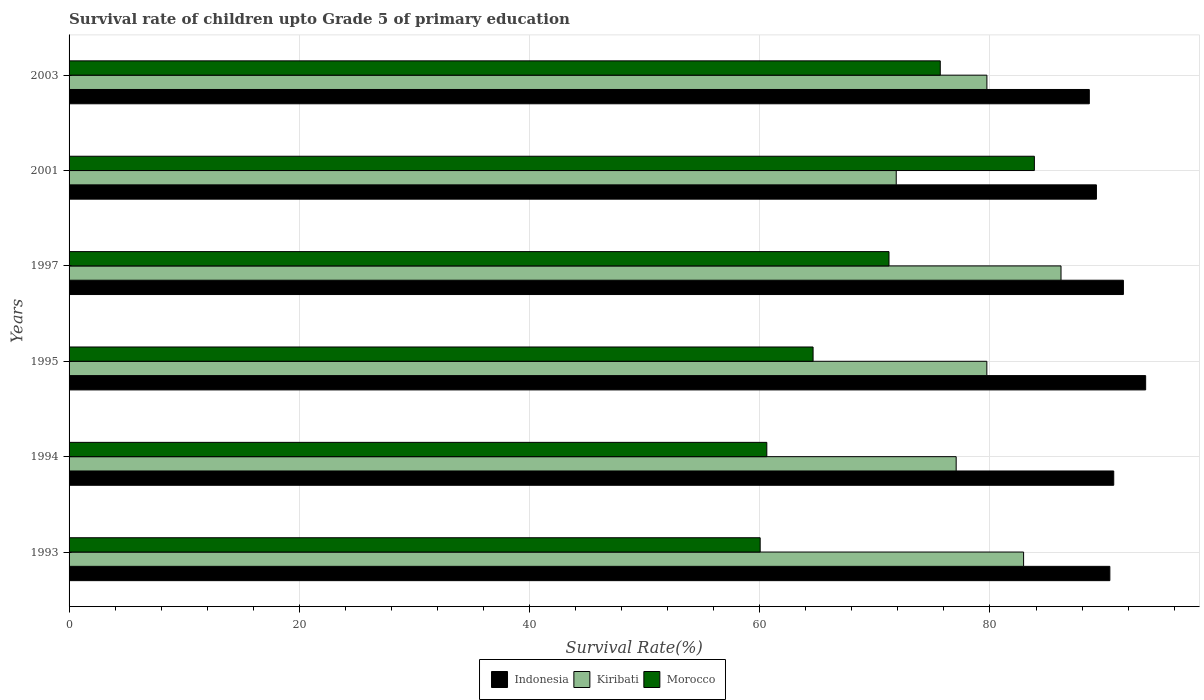How many different coloured bars are there?
Give a very brief answer. 3. How many groups of bars are there?
Provide a succinct answer. 6. Are the number of bars per tick equal to the number of legend labels?
Make the answer very short. Yes. Are the number of bars on each tick of the Y-axis equal?
Provide a short and direct response. Yes. How many bars are there on the 4th tick from the bottom?
Keep it short and to the point. 3. In how many cases, is the number of bars for a given year not equal to the number of legend labels?
Your answer should be compact. 0. What is the survival rate of children in Kiribati in 1995?
Your answer should be very brief. 79.73. Across all years, what is the maximum survival rate of children in Morocco?
Keep it short and to the point. 83.86. Across all years, what is the minimum survival rate of children in Morocco?
Your answer should be compact. 60.04. In which year was the survival rate of children in Morocco minimum?
Give a very brief answer. 1993. What is the total survival rate of children in Indonesia in the graph?
Your answer should be very brief. 544.16. What is the difference between the survival rate of children in Kiribati in 1995 and that in 2003?
Provide a short and direct response. -0.01. What is the difference between the survival rate of children in Morocco in 1997 and the survival rate of children in Indonesia in 2001?
Your answer should be very brief. -18.02. What is the average survival rate of children in Morocco per year?
Your answer should be very brief. 69.34. In the year 1993, what is the difference between the survival rate of children in Indonesia and survival rate of children in Kiribati?
Provide a short and direct response. 7.49. What is the ratio of the survival rate of children in Morocco in 1993 to that in 2001?
Provide a succinct answer. 0.72. Is the survival rate of children in Indonesia in 1994 less than that in 2001?
Offer a very short reply. No. Is the difference between the survival rate of children in Indonesia in 1993 and 1994 greater than the difference between the survival rate of children in Kiribati in 1993 and 1994?
Make the answer very short. No. What is the difference between the highest and the second highest survival rate of children in Kiribati?
Give a very brief answer. 3.25. What is the difference between the highest and the lowest survival rate of children in Kiribati?
Give a very brief answer. 14.31. In how many years, is the survival rate of children in Morocco greater than the average survival rate of children in Morocco taken over all years?
Your response must be concise. 3. Is the sum of the survival rate of children in Kiribati in 1997 and 2001 greater than the maximum survival rate of children in Indonesia across all years?
Your response must be concise. Yes. What does the 3rd bar from the top in 2001 represents?
Ensure brevity in your answer.  Indonesia. How many bars are there?
Your response must be concise. 18. How many years are there in the graph?
Your response must be concise. 6. Does the graph contain any zero values?
Provide a short and direct response. No. Does the graph contain grids?
Make the answer very short. Yes. What is the title of the graph?
Ensure brevity in your answer.  Survival rate of children upto Grade 5 of primary education. Does "Malaysia" appear as one of the legend labels in the graph?
Your response must be concise. No. What is the label or title of the X-axis?
Keep it short and to the point. Survival Rate(%). What is the Survival Rate(%) in Indonesia in 1993?
Make the answer very short. 90.41. What is the Survival Rate(%) of Kiribati in 1993?
Offer a terse response. 82.92. What is the Survival Rate(%) in Morocco in 1993?
Give a very brief answer. 60.04. What is the Survival Rate(%) of Indonesia in 1994?
Provide a succinct answer. 90.75. What is the Survival Rate(%) in Kiribati in 1994?
Give a very brief answer. 77.06. What is the Survival Rate(%) in Morocco in 1994?
Give a very brief answer. 60.61. What is the Survival Rate(%) of Indonesia in 1995?
Your answer should be very brief. 93.52. What is the Survival Rate(%) in Kiribati in 1995?
Provide a short and direct response. 79.73. What is the Survival Rate(%) of Morocco in 1995?
Ensure brevity in your answer.  64.63. What is the Survival Rate(%) in Indonesia in 1997?
Ensure brevity in your answer.  91.59. What is the Survival Rate(%) of Kiribati in 1997?
Provide a short and direct response. 86.17. What is the Survival Rate(%) of Morocco in 1997?
Ensure brevity in your answer.  71.23. What is the Survival Rate(%) in Indonesia in 2001?
Make the answer very short. 89.25. What is the Survival Rate(%) of Kiribati in 2001?
Ensure brevity in your answer.  71.86. What is the Survival Rate(%) in Morocco in 2001?
Your answer should be compact. 83.86. What is the Survival Rate(%) in Indonesia in 2003?
Your answer should be compact. 88.63. What is the Survival Rate(%) of Kiribati in 2003?
Provide a short and direct response. 79.73. What is the Survival Rate(%) of Morocco in 2003?
Ensure brevity in your answer.  75.68. Across all years, what is the maximum Survival Rate(%) in Indonesia?
Give a very brief answer. 93.52. Across all years, what is the maximum Survival Rate(%) in Kiribati?
Provide a short and direct response. 86.17. Across all years, what is the maximum Survival Rate(%) of Morocco?
Make the answer very short. 83.86. Across all years, what is the minimum Survival Rate(%) of Indonesia?
Give a very brief answer. 88.63. Across all years, what is the minimum Survival Rate(%) in Kiribati?
Offer a very short reply. 71.86. Across all years, what is the minimum Survival Rate(%) in Morocco?
Your answer should be very brief. 60.04. What is the total Survival Rate(%) of Indonesia in the graph?
Keep it short and to the point. 544.16. What is the total Survival Rate(%) in Kiribati in the graph?
Your response must be concise. 477.47. What is the total Survival Rate(%) in Morocco in the graph?
Make the answer very short. 416.05. What is the difference between the Survival Rate(%) in Indonesia in 1993 and that in 1994?
Ensure brevity in your answer.  -0.34. What is the difference between the Survival Rate(%) of Kiribati in 1993 and that in 1994?
Your answer should be very brief. 5.86. What is the difference between the Survival Rate(%) in Morocco in 1993 and that in 1994?
Provide a short and direct response. -0.58. What is the difference between the Survival Rate(%) of Indonesia in 1993 and that in 1995?
Your response must be concise. -3.11. What is the difference between the Survival Rate(%) of Kiribati in 1993 and that in 1995?
Your answer should be very brief. 3.19. What is the difference between the Survival Rate(%) of Morocco in 1993 and that in 1995?
Provide a short and direct response. -4.6. What is the difference between the Survival Rate(%) in Indonesia in 1993 and that in 1997?
Keep it short and to the point. -1.18. What is the difference between the Survival Rate(%) in Kiribati in 1993 and that in 1997?
Ensure brevity in your answer.  -3.25. What is the difference between the Survival Rate(%) of Morocco in 1993 and that in 1997?
Your answer should be very brief. -11.19. What is the difference between the Survival Rate(%) in Indonesia in 1993 and that in 2001?
Offer a terse response. 1.17. What is the difference between the Survival Rate(%) in Kiribati in 1993 and that in 2001?
Offer a terse response. 11.06. What is the difference between the Survival Rate(%) in Morocco in 1993 and that in 2001?
Provide a short and direct response. -23.82. What is the difference between the Survival Rate(%) in Indonesia in 1993 and that in 2003?
Give a very brief answer. 1.78. What is the difference between the Survival Rate(%) of Kiribati in 1993 and that in 2003?
Give a very brief answer. 3.19. What is the difference between the Survival Rate(%) in Morocco in 1993 and that in 2003?
Make the answer very short. -15.64. What is the difference between the Survival Rate(%) of Indonesia in 1994 and that in 1995?
Provide a short and direct response. -2.77. What is the difference between the Survival Rate(%) in Kiribati in 1994 and that in 1995?
Your answer should be very brief. -2.66. What is the difference between the Survival Rate(%) in Morocco in 1994 and that in 1995?
Your response must be concise. -4.02. What is the difference between the Survival Rate(%) of Indonesia in 1994 and that in 1997?
Ensure brevity in your answer.  -0.84. What is the difference between the Survival Rate(%) of Kiribati in 1994 and that in 1997?
Your answer should be very brief. -9.11. What is the difference between the Survival Rate(%) of Morocco in 1994 and that in 1997?
Ensure brevity in your answer.  -10.61. What is the difference between the Survival Rate(%) of Indonesia in 1994 and that in 2001?
Offer a terse response. 1.5. What is the difference between the Survival Rate(%) of Kiribati in 1994 and that in 2001?
Your answer should be very brief. 5.21. What is the difference between the Survival Rate(%) of Morocco in 1994 and that in 2001?
Ensure brevity in your answer.  -23.24. What is the difference between the Survival Rate(%) in Indonesia in 1994 and that in 2003?
Offer a very short reply. 2.12. What is the difference between the Survival Rate(%) of Kiribati in 1994 and that in 2003?
Your answer should be compact. -2.67. What is the difference between the Survival Rate(%) in Morocco in 1994 and that in 2003?
Provide a short and direct response. -15.07. What is the difference between the Survival Rate(%) in Indonesia in 1995 and that in 1997?
Give a very brief answer. 1.93. What is the difference between the Survival Rate(%) in Kiribati in 1995 and that in 1997?
Offer a terse response. -6.44. What is the difference between the Survival Rate(%) of Morocco in 1995 and that in 1997?
Provide a short and direct response. -6.6. What is the difference between the Survival Rate(%) of Indonesia in 1995 and that in 2001?
Offer a very short reply. 4.28. What is the difference between the Survival Rate(%) in Kiribati in 1995 and that in 2001?
Make the answer very short. 7.87. What is the difference between the Survival Rate(%) in Morocco in 1995 and that in 2001?
Provide a short and direct response. -19.22. What is the difference between the Survival Rate(%) in Indonesia in 1995 and that in 2003?
Your response must be concise. 4.9. What is the difference between the Survival Rate(%) of Kiribati in 1995 and that in 2003?
Offer a very short reply. -0.01. What is the difference between the Survival Rate(%) in Morocco in 1995 and that in 2003?
Provide a succinct answer. -11.05. What is the difference between the Survival Rate(%) of Indonesia in 1997 and that in 2001?
Provide a succinct answer. 2.34. What is the difference between the Survival Rate(%) in Kiribati in 1997 and that in 2001?
Keep it short and to the point. 14.31. What is the difference between the Survival Rate(%) in Morocco in 1997 and that in 2001?
Your answer should be compact. -12.63. What is the difference between the Survival Rate(%) in Indonesia in 1997 and that in 2003?
Offer a terse response. 2.96. What is the difference between the Survival Rate(%) in Kiribati in 1997 and that in 2003?
Your response must be concise. 6.44. What is the difference between the Survival Rate(%) of Morocco in 1997 and that in 2003?
Keep it short and to the point. -4.45. What is the difference between the Survival Rate(%) in Indonesia in 2001 and that in 2003?
Keep it short and to the point. 0.62. What is the difference between the Survival Rate(%) of Kiribati in 2001 and that in 2003?
Provide a succinct answer. -7.88. What is the difference between the Survival Rate(%) of Morocco in 2001 and that in 2003?
Your response must be concise. 8.18. What is the difference between the Survival Rate(%) of Indonesia in 1993 and the Survival Rate(%) of Kiribati in 1994?
Give a very brief answer. 13.35. What is the difference between the Survival Rate(%) in Indonesia in 1993 and the Survival Rate(%) in Morocco in 1994?
Make the answer very short. 29.8. What is the difference between the Survival Rate(%) of Kiribati in 1993 and the Survival Rate(%) of Morocco in 1994?
Provide a short and direct response. 22.31. What is the difference between the Survival Rate(%) of Indonesia in 1993 and the Survival Rate(%) of Kiribati in 1995?
Your response must be concise. 10.69. What is the difference between the Survival Rate(%) of Indonesia in 1993 and the Survival Rate(%) of Morocco in 1995?
Your answer should be compact. 25.78. What is the difference between the Survival Rate(%) in Kiribati in 1993 and the Survival Rate(%) in Morocco in 1995?
Make the answer very short. 18.29. What is the difference between the Survival Rate(%) of Indonesia in 1993 and the Survival Rate(%) of Kiribati in 1997?
Keep it short and to the point. 4.24. What is the difference between the Survival Rate(%) of Indonesia in 1993 and the Survival Rate(%) of Morocco in 1997?
Provide a succinct answer. 19.19. What is the difference between the Survival Rate(%) of Kiribati in 1993 and the Survival Rate(%) of Morocco in 1997?
Provide a succinct answer. 11.69. What is the difference between the Survival Rate(%) in Indonesia in 1993 and the Survival Rate(%) in Kiribati in 2001?
Make the answer very short. 18.56. What is the difference between the Survival Rate(%) in Indonesia in 1993 and the Survival Rate(%) in Morocco in 2001?
Keep it short and to the point. 6.56. What is the difference between the Survival Rate(%) in Kiribati in 1993 and the Survival Rate(%) in Morocco in 2001?
Ensure brevity in your answer.  -0.94. What is the difference between the Survival Rate(%) in Indonesia in 1993 and the Survival Rate(%) in Kiribati in 2003?
Your response must be concise. 10.68. What is the difference between the Survival Rate(%) of Indonesia in 1993 and the Survival Rate(%) of Morocco in 2003?
Offer a very short reply. 14.73. What is the difference between the Survival Rate(%) of Kiribati in 1993 and the Survival Rate(%) of Morocco in 2003?
Your answer should be very brief. 7.24. What is the difference between the Survival Rate(%) of Indonesia in 1994 and the Survival Rate(%) of Kiribati in 1995?
Offer a very short reply. 11.02. What is the difference between the Survival Rate(%) in Indonesia in 1994 and the Survival Rate(%) in Morocco in 1995?
Ensure brevity in your answer.  26.12. What is the difference between the Survival Rate(%) of Kiribati in 1994 and the Survival Rate(%) of Morocco in 1995?
Your answer should be very brief. 12.43. What is the difference between the Survival Rate(%) in Indonesia in 1994 and the Survival Rate(%) in Kiribati in 1997?
Provide a short and direct response. 4.58. What is the difference between the Survival Rate(%) in Indonesia in 1994 and the Survival Rate(%) in Morocco in 1997?
Your response must be concise. 19.52. What is the difference between the Survival Rate(%) of Kiribati in 1994 and the Survival Rate(%) of Morocco in 1997?
Make the answer very short. 5.84. What is the difference between the Survival Rate(%) in Indonesia in 1994 and the Survival Rate(%) in Kiribati in 2001?
Give a very brief answer. 18.89. What is the difference between the Survival Rate(%) in Indonesia in 1994 and the Survival Rate(%) in Morocco in 2001?
Keep it short and to the point. 6.89. What is the difference between the Survival Rate(%) of Kiribati in 1994 and the Survival Rate(%) of Morocco in 2001?
Your answer should be compact. -6.79. What is the difference between the Survival Rate(%) in Indonesia in 1994 and the Survival Rate(%) in Kiribati in 2003?
Your answer should be compact. 11.02. What is the difference between the Survival Rate(%) of Indonesia in 1994 and the Survival Rate(%) of Morocco in 2003?
Your answer should be very brief. 15.07. What is the difference between the Survival Rate(%) in Kiribati in 1994 and the Survival Rate(%) in Morocco in 2003?
Provide a succinct answer. 1.38. What is the difference between the Survival Rate(%) in Indonesia in 1995 and the Survival Rate(%) in Kiribati in 1997?
Make the answer very short. 7.35. What is the difference between the Survival Rate(%) of Indonesia in 1995 and the Survival Rate(%) of Morocco in 1997?
Offer a terse response. 22.3. What is the difference between the Survival Rate(%) in Kiribati in 1995 and the Survival Rate(%) in Morocco in 1997?
Provide a succinct answer. 8.5. What is the difference between the Survival Rate(%) in Indonesia in 1995 and the Survival Rate(%) in Kiribati in 2001?
Ensure brevity in your answer.  21.67. What is the difference between the Survival Rate(%) in Indonesia in 1995 and the Survival Rate(%) in Morocco in 2001?
Provide a succinct answer. 9.67. What is the difference between the Survival Rate(%) of Kiribati in 1995 and the Survival Rate(%) of Morocco in 2001?
Your answer should be very brief. -4.13. What is the difference between the Survival Rate(%) in Indonesia in 1995 and the Survival Rate(%) in Kiribati in 2003?
Offer a terse response. 13.79. What is the difference between the Survival Rate(%) in Indonesia in 1995 and the Survival Rate(%) in Morocco in 2003?
Give a very brief answer. 17.84. What is the difference between the Survival Rate(%) in Kiribati in 1995 and the Survival Rate(%) in Morocco in 2003?
Give a very brief answer. 4.05. What is the difference between the Survival Rate(%) in Indonesia in 1997 and the Survival Rate(%) in Kiribati in 2001?
Your response must be concise. 19.73. What is the difference between the Survival Rate(%) of Indonesia in 1997 and the Survival Rate(%) of Morocco in 2001?
Your answer should be very brief. 7.73. What is the difference between the Survival Rate(%) in Kiribati in 1997 and the Survival Rate(%) in Morocco in 2001?
Offer a terse response. 2.31. What is the difference between the Survival Rate(%) in Indonesia in 1997 and the Survival Rate(%) in Kiribati in 2003?
Give a very brief answer. 11.86. What is the difference between the Survival Rate(%) in Indonesia in 1997 and the Survival Rate(%) in Morocco in 2003?
Provide a succinct answer. 15.91. What is the difference between the Survival Rate(%) in Kiribati in 1997 and the Survival Rate(%) in Morocco in 2003?
Provide a short and direct response. 10.49. What is the difference between the Survival Rate(%) of Indonesia in 2001 and the Survival Rate(%) of Kiribati in 2003?
Provide a succinct answer. 9.51. What is the difference between the Survival Rate(%) of Indonesia in 2001 and the Survival Rate(%) of Morocco in 2003?
Your response must be concise. 13.57. What is the difference between the Survival Rate(%) of Kiribati in 2001 and the Survival Rate(%) of Morocco in 2003?
Your response must be concise. -3.82. What is the average Survival Rate(%) of Indonesia per year?
Your answer should be very brief. 90.69. What is the average Survival Rate(%) in Kiribati per year?
Offer a very short reply. 79.58. What is the average Survival Rate(%) in Morocco per year?
Offer a very short reply. 69.34. In the year 1993, what is the difference between the Survival Rate(%) of Indonesia and Survival Rate(%) of Kiribati?
Give a very brief answer. 7.49. In the year 1993, what is the difference between the Survival Rate(%) in Indonesia and Survival Rate(%) in Morocco?
Ensure brevity in your answer.  30.38. In the year 1993, what is the difference between the Survival Rate(%) in Kiribati and Survival Rate(%) in Morocco?
Keep it short and to the point. 22.88. In the year 1994, what is the difference between the Survival Rate(%) in Indonesia and Survival Rate(%) in Kiribati?
Your answer should be very brief. 13.69. In the year 1994, what is the difference between the Survival Rate(%) in Indonesia and Survival Rate(%) in Morocco?
Keep it short and to the point. 30.14. In the year 1994, what is the difference between the Survival Rate(%) of Kiribati and Survival Rate(%) of Morocco?
Make the answer very short. 16.45. In the year 1995, what is the difference between the Survival Rate(%) in Indonesia and Survival Rate(%) in Kiribati?
Ensure brevity in your answer.  13.8. In the year 1995, what is the difference between the Survival Rate(%) of Indonesia and Survival Rate(%) of Morocco?
Your answer should be compact. 28.89. In the year 1995, what is the difference between the Survival Rate(%) in Kiribati and Survival Rate(%) in Morocco?
Your answer should be compact. 15.09. In the year 1997, what is the difference between the Survival Rate(%) in Indonesia and Survival Rate(%) in Kiribati?
Offer a very short reply. 5.42. In the year 1997, what is the difference between the Survival Rate(%) of Indonesia and Survival Rate(%) of Morocco?
Your response must be concise. 20.36. In the year 1997, what is the difference between the Survival Rate(%) of Kiribati and Survival Rate(%) of Morocco?
Make the answer very short. 14.94. In the year 2001, what is the difference between the Survival Rate(%) of Indonesia and Survival Rate(%) of Kiribati?
Give a very brief answer. 17.39. In the year 2001, what is the difference between the Survival Rate(%) in Indonesia and Survival Rate(%) in Morocco?
Keep it short and to the point. 5.39. In the year 2001, what is the difference between the Survival Rate(%) in Kiribati and Survival Rate(%) in Morocco?
Make the answer very short. -12. In the year 2003, what is the difference between the Survival Rate(%) in Indonesia and Survival Rate(%) in Kiribati?
Keep it short and to the point. 8.9. In the year 2003, what is the difference between the Survival Rate(%) of Indonesia and Survival Rate(%) of Morocco?
Keep it short and to the point. 12.95. In the year 2003, what is the difference between the Survival Rate(%) of Kiribati and Survival Rate(%) of Morocco?
Ensure brevity in your answer.  4.05. What is the ratio of the Survival Rate(%) of Indonesia in 1993 to that in 1994?
Make the answer very short. 1. What is the ratio of the Survival Rate(%) in Kiribati in 1993 to that in 1994?
Offer a terse response. 1.08. What is the ratio of the Survival Rate(%) in Indonesia in 1993 to that in 1995?
Your answer should be very brief. 0.97. What is the ratio of the Survival Rate(%) of Morocco in 1993 to that in 1995?
Give a very brief answer. 0.93. What is the ratio of the Survival Rate(%) of Indonesia in 1993 to that in 1997?
Provide a short and direct response. 0.99. What is the ratio of the Survival Rate(%) in Kiribati in 1993 to that in 1997?
Provide a short and direct response. 0.96. What is the ratio of the Survival Rate(%) of Morocco in 1993 to that in 1997?
Offer a terse response. 0.84. What is the ratio of the Survival Rate(%) of Indonesia in 1993 to that in 2001?
Offer a terse response. 1.01. What is the ratio of the Survival Rate(%) in Kiribati in 1993 to that in 2001?
Your answer should be very brief. 1.15. What is the ratio of the Survival Rate(%) in Morocco in 1993 to that in 2001?
Give a very brief answer. 0.72. What is the ratio of the Survival Rate(%) of Indonesia in 1993 to that in 2003?
Offer a terse response. 1.02. What is the ratio of the Survival Rate(%) in Morocco in 1993 to that in 2003?
Offer a very short reply. 0.79. What is the ratio of the Survival Rate(%) in Indonesia in 1994 to that in 1995?
Give a very brief answer. 0.97. What is the ratio of the Survival Rate(%) of Kiribati in 1994 to that in 1995?
Make the answer very short. 0.97. What is the ratio of the Survival Rate(%) in Morocco in 1994 to that in 1995?
Offer a very short reply. 0.94. What is the ratio of the Survival Rate(%) of Indonesia in 1994 to that in 1997?
Give a very brief answer. 0.99. What is the ratio of the Survival Rate(%) in Kiribati in 1994 to that in 1997?
Your response must be concise. 0.89. What is the ratio of the Survival Rate(%) in Morocco in 1994 to that in 1997?
Give a very brief answer. 0.85. What is the ratio of the Survival Rate(%) in Indonesia in 1994 to that in 2001?
Provide a short and direct response. 1.02. What is the ratio of the Survival Rate(%) of Kiribati in 1994 to that in 2001?
Offer a terse response. 1.07. What is the ratio of the Survival Rate(%) of Morocco in 1994 to that in 2001?
Keep it short and to the point. 0.72. What is the ratio of the Survival Rate(%) of Indonesia in 1994 to that in 2003?
Your answer should be very brief. 1.02. What is the ratio of the Survival Rate(%) of Kiribati in 1994 to that in 2003?
Ensure brevity in your answer.  0.97. What is the ratio of the Survival Rate(%) in Morocco in 1994 to that in 2003?
Offer a terse response. 0.8. What is the ratio of the Survival Rate(%) in Indonesia in 1995 to that in 1997?
Your answer should be very brief. 1.02. What is the ratio of the Survival Rate(%) of Kiribati in 1995 to that in 1997?
Offer a terse response. 0.93. What is the ratio of the Survival Rate(%) of Morocco in 1995 to that in 1997?
Your answer should be compact. 0.91. What is the ratio of the Survival Rate(%) of Indonesia in 1995 to that in 2001?
Make the answer very short. 1.05. What is the ratio of the Survival Rate(%) in Kiribati in 1995 to that in 2001?
Provide a succinct answer. 1.11. What is the ratio of the Survival Rate(%) of Morocco in 1995 to that in 2001?
Keep it short and to the point. 0.77. What is the ratio of the Survival Rate(%) of Indonesia in 1995 to that in 2003?
Make the answer very short. 1.06. What is the ratio of the Survival Rate(%) in Kiribati in 1995 to that in 2003?
Make the answer very short. 1. What is the ratio of the Survival Rate(%) of Morocco in 1995 to that in 2003?
Give a very brief answer. 0.85. What is the ratio of the Survival Rate(%) of Indonesia in 1997 to that in 2001?
Your answer should be compact. 1.03. What is the ratio of the Survival Rate(%) in Kiribati in 1997 to that in 2001?
Provide a succinct answer. 1.2. What is the ratio of the Survival Rate(%) of Morocco in 1997 to that in 2001?
Offer a very short reply. 0.85. What is the ratio of the Survival Rate(%) of Indonesia in 1997 to that in 2003?
Provide a succinct answer. 1.03. What is the ratio of the Survival Rate(%) in Kiribati in 1997 to that in 2003?
Provide a succinct answer. 1.08. What is the ratio of the Survival Rate(%) of Kiribati in 2001 to that in 2003?
Offer a very short reply. 0.9. What is the ratio of the Survival Rate(%) of Morocco in 2001 to that in 2003?
Provide a short and direct response. 1.11. What is the difference between the highest and the second highest Survival Rate(%) in Indonesia?
Provide a short and direct response. 1.93. What is the difference between the highest and the second highest Survival Rate(%) in Kiribati?
Offer a very short reply. 3.25. What is the difference between the highest and the second highest Survival Rate(%) in Morocco?
Provide a succinct answer. 8.18. What is the difference between the highest and the lowest Survival Rate(%) in Indonesia?
Offer a terse response. 4.9. What is the difference between the highest and the lowest Survival Rate(%) in Kiribati?
Your response must be concise. 14.31. What is the difference between the highest and the lowest Survival Rate(%) in Morocco?
Provide a short and direct response. 23.82. 